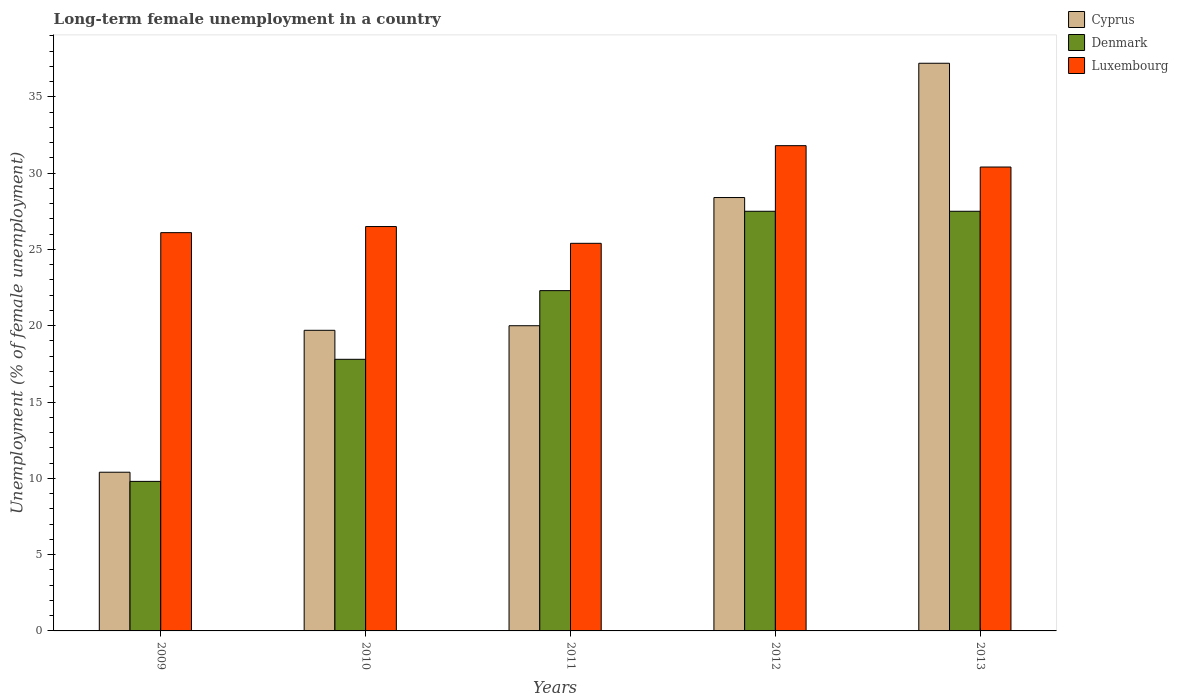How many different coloured bars are there?
Ensure brevity in your answer.  3. How many groups of bars are there?
Your answer should be very brief. 5. Are the number of bars per tick equal to the number of legend labels?
Your answer should be compact. Yes. Are the number of bars on each tick of the X-axis equal?
Your response must be concise. Yes. In how many cases, is the number of bars for a given year not equal to the number of legend labels?
Give a very brief answer. 0. What is the percentage of long-term unemployed female population in Cyprus in 2013?
Provide a succinct answer. 37.2. Across all years, what is the maximum percentage of long-term unemployed female population in Luxembourg?
Provide a succinct answer. 31.8. Across all years, what is the minimum percentage of long-term unemployed female population in Luxembourg?
Make the answer very short. 25.4. In which year was the percentage of long-term unemployed female population in Cyprus maximum?
Offer a very short reply. 2013. What is the total percentage of long-term unemployed female population in Luxembourg in the graph?
Provide a succinct answer. 140.2. What is the difference between the percentage of long-term unemployed female population in Denmark in 2009 and that in 2012?
Provide a short and direct response. -17.7. What is the difference between the percentage of long-term unemployed female population in Denmark in 2011 and the percentage of long-term unemployed female population in Luxembourg in 2013?
Ensure brevity in your answer.  -8.1. What is the average percentage of long-term unemployed female population in Denmark per year?
Provide a succinct answer. 20.98. In the year 2009, what is the difference between the percentage of long-term unemployed female population in Luxembourg and percentage of long-term unemployed female population in Cyprus?
Make the answer very short. 15.7. In how many years, is the percentage of long-term unemployed female population in Denmark greater than 32 %?
Keep it short and to the point. 0. What is the ratio of the percentage of long-term unemployed female population in Luxembourg in 2010 to that in 2012?
Keep it short and to the point. 0.83. Is the percentage of long-term unemployed female population in Cyprus in 2012 less than that in 2013?
Offer a terse response. Yes. Is the difference between the percentage of long-term unemployed female population in Luxembourg in 2011 and 2013 greater than the difference between the percentage of long-term unemployed female population in Cyprus in 2011 and 2013?
Offer a very short reply. Yes. What is the difference between the highest and the second highest percentage of long-term unemployed female population in Luxembourg?
Provide a short and direct response. 1.4. What is the difference between the highest and the lowest percentage of long-term unemployed female population in Luxembourg?
Give a very brief answer. 6.4. Is the sum of the percentage of long-term unemployed female population in Luxembourg in 2009 and 2010 greater than the maximum percentage of long-term unemployed female population in Denmark across all years?
Your answer should be very brief. Yes. What does the 3rd bar from the right in 2009 represents?
Ensure brevity in your answer.  Cyprus. Are all the bars in the graph horizontal?
Offer a terse response. No. Are the values on the major ticks of Y-axis written in scientific E-notation?
Provide a short and direct response. No. Does the graph contain any zero values?
Provide a short and direct response. No. Does the graph contain grids?
Provide a short and direct response. No. Where does the legend appear in the graph?
Keep it short and to the point. Top right. How many legend labels are there?
Offer a very short reply. 3. How are the legend labels stacked?
Make the answer very short. Vertical. What is the title of the graph?
Keep it short and to the point. Long-term female unemployment in a country. Does "Iraq" appear as one of the legend labels in the graph?
Your response must be concise. No. What is the label or title of the Y-axis?
Your answer should be very brief. Unemployment (% of female unemployment). What is the Unemployment (% of female unemployment) in Cyprus in 2009?
Provide a succinct answer. 10.4. What is the Unemployment (% of female unemployment) in Denmark in 2009?
Make the answer very short. 9.8. What is the Unemployment (% of female unemployment) of Luxembourg in 2009?
Provide a succinct answer. 26.1. What is the Unemployment (% of female unemployment) of Cyprus in 2010?
Ensure brevity in your answer.  19.7. What is the Unemployment (% of female unemployment) in Denmark in 2010?
Keep it short and to the point. 17.8. What is the Unemployment (% of female unemployment) in Luxembourg in 2010?
Your response must be concise. 26.5. What is the Unemployment (% of female unemployment) in Denmark in 2011?
Keep it short and to the point. 22.3. What is the Unemployment (% of female unemployment) of Luxembourg in 2011?
Your answer should be very brief. 25.4. What is the Unemployment (% of female unemployment) of Cyprus in 2012?
Ensure brevity in your answer.  28.4. What is the Unemployment (% of female unemployment) in Denmark in 2012?
Offer a terse response. 27.5. What is the Unemployment (% of female unemployment) in Luxembourg in 2012?
Offer a very short reply. 31.8. What is the Unemployment (% of female unemployment) of Cyprus in 2013?
Ensure brevity in your answer.  37.2. What is the Unemployment (% of female unemployment) in Luxembourg in 2013?
Make the answer very short. 30.4. Across all years, what is the maximum Unemployment (% of female unemployment) of Cyprus?
Keep it short and to the point. 37.2. Across all years, what is the maximum Unemployment (% of female unemployment) in Denmark?
Your answer should be compact. 27.5. Across all years, what is the maximum Unemployment (% of female unemployment) in Luxembourg?
Provide a short and direct response. 31.8. Across all years, what is the minimum Unemployment (% of female unemployment) of Cyprus?
Your response must be concise. 10.4. Across all years, what is the minimum Unemployment (% of female unemployment) of Denmark?
Your answer should be compact. 9.8. Across all years, what is the minimum Unemployment (% of female unemployment) of Luxembourg?
Ensure brevity in your answer.  25.4. What is the total Unemployment (% of female unemployment) of Cyprus in the graph?
Keep it short and to the point. 115.7. What is the total Unemployment (% of female unemployment) of Denmark in the graph?
Keep it short and to the point. 104.9. What is the total Unemployment (% of female unemployment) of Luxembourg in the graph?
Offer a terse response. 140.2. What is the difference between the Unemployment (% of female unemployment) in Denmark in 2009 and that in 2010?
Offer a terse response. -8. What is the difference between the Unemployment (% of female unemployment) of Luxembourg in 2009 and that in 2010?
Offer a very short reply. -0.4. What is the difference between the Unemployment (% of female unemployment) of Denmark in 2009 and that in 2011?
Give a very brief answer. -12.5. What is the difference between the Unemployment (% of female unemployment) in Denmark in 2009 and that in 2012?
Provide a succinct answer. -17.7. What is the difference between the Unemployment (% of female unemployment) in Cyprus in 2009 and that in 2013?
Keep it short and to the point. -26.8. What is the difference between the Unemployment (% of female unemployment) of Denmark in 2009 and that in 2013?
Provide a short and direct response. -17.7. What is the difference between the Unemployment (% of female unemployment) in Luxembourg in 2009 and that in 2013?
Offer a terse response. -4.3. What is the difference between the Unemployment (% of female unemployment) of Cyprus in 2010 and that in 2011?
Give a very brief answer. -0.3. What is the difference between the Unemployment (% of female unemployment) of Luxembourg in 2010 and that in 2011?
Give a very brief answer. 1.1. What is the difference between the Unemployment (% of female unemployment) of Cyprus in 2010 and that in 2012?
Your answer should be compact. -8.7. What is the difference between the Unemployment (% of female unemployment) of Cyprus in 2010 and that in 2013?
Give a very brief answer. -17.5. What is the difference between the Unemployment (% of female unemployment) of Denmark in 2010 and that in 2013?
Your response must be concise. -9.7. What is the difference between the Unemployment (% of female unemployment) in Luxembourg in 2010 and that in 2013?
Your answer should be compact. -3.9. What is the difference between the Unemployment (% of female unemployment) in Cyprus in 2011 and that in 2012?
Offer a very short reply. -8.4. What is the difference between the Unemployment (% of female unemployment) of Luxembourg in 2011 and that in 2012?
Your response must be concise. -6.4. What is the difference between the Unemployment (% of female unemployment) in Cyprus in 2011 and that in 2013?
Offer a terse response. -17.2. What is the difference between the Unemployment (% of female unemployment) of Denmark in 2011 and that in 2013?
Keep it short and to the point. -5.2. What is the difference between the Unemployment (% of female unemployment) in Cyprus in 2012 and that in 2013?
Keep it short and to the point. -8.8. What is the difference between the Unemployment (% of female unemployment) of Luxembourg in 2012 and that in 2013?
Offer a terse response. 1.4. What is the difference between the Unemployment (% of female unemployment) of Cyprus in 2009 and the Unemployment (% of female unemployment) of Denmark in 2010?
Offer a terse response. -7.4. What is the difference between the Unemployment (% of female unemployment) of Cyprus in 2009 and the Unemployment (% of female unemployment) of Luxembourg in 2010?
Your answer should be compact. -16.1. What is the difference between the Unemployment (% of female unemployment) in Denmark in 2009 and the Unemployment (% of female unemployment) in Luxembourg in 2010?
Ensure brevity in your answer.  -16.7. What is the difference between the Unemployment (% of female unemployment) in Cyprus in 2009 and the Unemployment (% of female unemployment) in Luxembourg in 2011?
Make the answer very short. -15. What is the difference between the Unemployment (% of female unemployment) in Denmark in 2009 and the Unemployment (% of female unemployment) in Luxembourg in 2011?
Your answer should be very brief. -15.6. What is the difference between the Unemployment (% of female unemployment) in Cyprus in 2009 and the Unemployment (% of female unemployment) in Denmark in 2012?
Provide a succinct answer. -17.1. What is the difference between the Unemployment (% of female unemployment) of Cyprus in 2009 and the Unemployment (% of female unemployment) of Luxembourg in 2012?
Offer a very short reply. -21.4. What is the difference between the Unemployment (% of female unemployment) of Denmark in 2009 and the Unemployment (% of female unemployment) of Luxembourg in 2012?
Your answer should be very brief. -22. What is the difference between the Unemployment (% of female unemployment) in Cyprus in 2009 and the Unemployment (% of female unemployment) in Denmark in 2013?
Your answer should be compact. -17.1. What is the difference between the Unemployment (% of female unemployment) of Denmark in 2009 and the Unemployment (% of female unemployment) of Luxembourg in 2013?
Give a very brief answer. -20.6. What is the difference between the Unemployment (% of female unemployment) in Cyprus in 2010 and the Unemployment (% of female unemployment) in Denmark in 2011?
Keep it short and to the point. -2.6. What is the difference between the Unemployment (% of female unemployment) of Cyprus in 2010 and the Unemployment (% of female unemployment) of Denmark in 2012?
Keep it short and to the point. -7.8. What is the difference between the Unemployment (% of female unemployment) of Cyprus in 2010 and the Unemployment (% of female unemployment) of Luxembourg in 2012?
Give a very brief answer. -12.1. What is the difference between the Unemployment (% of female unemployment) of Denmark in 2010 and the Unemployment (% of female unemployment) of Luxembourg in 2012?
Your response must be concise. -14. What is the difference between the Unemployment (% of female unemployment) in Cyprus in 2010 and the Unemployment (% of female unemployment) in Luxembourg in 2013?
Provide a succinct answer. -10.7. What is the difference between the Unemployment (% of female unemployment) of Cyprus in 2011 and the Unemployment (% of female unemployment) of Denmark in 2012?
Offer a terse response. -7.5. What is the difference between the Unemployment (% of female unemployment) of Denmark in 2011 and the Unemployment (% of female unemployment) of Luxembourg in 2012?
Your response must be concise. -9.5. What is the difference between the Unemployment (% of female unemployment) of Cyprus in 2011 and the Unemployment (% of female unemployment) of Denmark in 2013?
Offer a very short reply. -7.5. What is the difference between the Unemployment (% of female unemployment) in Cyprus in 2011 and the Unemployment (% of female unemployment) in Luxembourg in 2013?
Offer a very short reply. -10.4. What is the difference between the Unemployment (% of female unemployment) of Denmark in 2011 and the Unemployment (% of female unemployment) of Luxembourg in 2013?
Ensure brevity in your answer.  -8.1. What is the difference between the Unemployment (% of female unemployment) of Cyprus in 2012 and the Unemployment (% of female unemployment) of Denmark in 2013?
Your response must be concise. 0.9. What is the difference between the Unemployment (% of female unemployment) in Cyprus in 2012 and the Unemployment (% of female unemployment) in Luxembourg in 2013?
Your response must be concise. -2. What is the difference between the Unemployment (% of female unemployment) in Denmark in 2012 and the Unemployment (% of female unemployment) in Luxembourg in 2013?
Provide a succinct answer. -2.9. What is the average Unemployment (% of female unemployment) of Cyprus per year?
Your response must be concise. 23.14. What is the average Unemployment (% of female unemployment) in Denmark per year?
Offer a terse response. 20.98. What is the average Unemployment (% of female unemployment) in Luxembourg per year?
Offer a terse response. 28.04. In the year 2009, what is the difference between the Unemployment (% of female unemployment) of Cyprus and Unemployment (% of female unemployment) of Denmark?
Offer a very short reply. 0.6. In the year 2009, what is the difference between the Unemployment (% of female unemployment) of Cyprus and Unemployment (% of female unemployment) of Luxembourg?
Ensure brevity in your answer.  -15.7. In the year 2009, what is the difference between the Unemployment (% of female unemployment) in Denmark and Unemployment (% of female unemployment) in Luxembourg?
Ensure brevity in your answer.  -16.3. In the year 2010, what is the difference between the Unemployment (% of female unemployment) of Cyprus and Unemployment (% of female unemployment) of Denmark?
Offer a terse response. 1.9. In the year 2010, what is the difference between the Unemployment (% of female unemployment) in Cyprus and Unemployment (% of female unemployment) in Luxembourg?
Offer a very short reply. -6.8. In the year 2011, what is the difference between the Unemployment (% of female unemployment) of Cyprus and Unemployment (% of female unemployment) of Denmark?
Provide a short and direct response. -2.3. In the year 2011, what is the difference between the Unemployment (% of female unemployment) in Cyprus and Unemployment (% of female unemployment) in Luxembourg?
Give a very brief answer. -5.4. In the year 2011, what is the difference between the Unemployment (% of female unemployment) in Denmark and Unemployment (% of female unemployment) in Luxembourg?
Provide a succinct answer. -3.1. In the year 2012, what is the difference between the Unemployment (% of female unemployment) in Cyprus and Unemployment (% of female unemployment) in Denmark?
Your response must be concise. 0.9. In the year 2012, what is the difference between the Unemployment (% of female unemployment) of Denmark and Unemployment (% of female unemployment) of Luxembourg?
Ensure brevity in your answer.  -4.3. In the year 2013, what is the difference between the Unemployment (% of female unemployment) of Cyprus and Unemployment (% of female unemployment) of Luxembourg?
Offer a terse response. 6.8. What is the ratio of the Unemployment (% of female unemployment) of Cyprus in 2009 to that in 2010?
Provide a short and direct response. 0.53. What is the ratio of the Unemployment (% of female unemployment) of Denmark in 2009 to that in 2010?
Provide a short and direct response. 0.55. What is the ratio of the Unemployment (% of female unemployment) of Luxembourg in 2009 to that in 2010?
Your answer should be very brief. 0.98. What is the ratio of the Unemployment (% of female unemployment) in Cyprus in 2009 to that in 2011?
Keep it short and to the point. 0.52. What is the ratio of the Unemployment (% of female unemployment) of Denmark in 2009 to that in 2011?
Your answer should be very brief. 0.44. What is the ratio of the Unemployment (% of female unemployment) of Luxembourg in 2009 to that in 2011?
Keep it short and to the point. 1.03. What is the ratio of the Unemployment (% of female unemployment) of Cyprus in 2009 to that in 2012?
Offer a terse response. 0.37. What is the ratio of the Unemployment (% of female unemployment) of Denmark in 2009 to that in 2012?
Offer a terse response. 0.36. What is the ratio of the Unemployment (% of female unemployment) of Luxembourg in 2009 to that in 2012?
Provide a succinct answer. 0.82. What is the ratio of the Unemployment (% of female unemployment) in Cyprus in 2009 to that in 2013?
Your response must be concise. 0.28. What is the ratio of the Unemployment (% of female unemployment) of Denmark in 2009 to that in 2013?
Offer a terse response. 0.36. What is the ratio of the Unemployment (% of female unemployment) of Luxembourg in 2009 to that in 2013?
Your answer should be compact. 0.86. What is the ratio of the Unemployment (% of female unemployment) in Denmark in 2010 to that in 2011?
Offer a very short reply. 0.8. What is the ratio of the Unemployment (% of female unemployment) of Luxembourg in 2010 to that in 2011?
Provide a short and direct response. 1.04. What is the ratio of the Unemployment (% of female unemployment) in Cyprus in 2010 to that in 2012?
Your answer should be very brief. 0.69. What is the ratio of the Unemployment (% of female unemployment) in Denmark in 2010 to that in 2012?
Give a very brief answer. 0.65. What is the ratio of the Unemployment (% of female unemployment) of Luxembourg in 2010 to that in 2012?
Your answer should be compact. 0.83. What is the ratio of the Unemployment (% of female unemployment) of Cyprus in 2010 to that in 2013?
Ensure brevity in your answer.  0.53. What is the ratio of the Unemployment (% of female unemployment) in Denmark in 2010 to that in 2013?
Your answer should be compact. 0.65. What is the ratio of the Unemployment (% of female unemployment) in Luxembourg in 2010 to that in 2013?
Provide a succinct answer. 0.87. What is the ratio of the Unemployment (% of female unemployment) in Cyprus in 2011 to that in 2012?
Provide a short and direct response. 0.7. What is the ratio of the Unemployment (% of female unemployment) in Denmark in 2011 to that in 2012?
Provide a short and direct response. 0.81. What is the ratio of the Unemployment (% of female unemployment) of Luxembourg in 2011 to that in 2012?
Your response must be concise. 0.8. What is the ratio of the Unemployment (% of female unemployment) in Cyprus in 2011 to that in 2013?
Keep it short and to the point. 0.54. What is the ratio of the Unemployment (% of female unemployment) of Denmark in 2011 to that in 2013?
Make the answer very short. 0.81. What is the ratio of the Unemployment (% of female unemployment) of Luxembourg in 2011 to that in 2013?
Make the answer very short. 0.84. What is the ratio of the Unemployment (% of female unemployment) of Cyprus in 2012 to that in 2013?
Your answer should be compact. 0.76. What is the ratio of the Unemployment (% of female unemployment) of Denmark in 2012 to that in 2013?
Ensure brevity in your answer.  1. What is the ratio of the Unemployment (% of female unemployment) in Luxembourg in 2012 to that in 2013?
Make the answer very short. 1.05. What is the difference between the highest and the second highest Unemployment (% of female unemployment) in Cyprus?
Make the answer very short. 8.8. What is the difference between the highest and the second highest Unemployment (% of female unemployment) of Denmark?
Keep it short and to the point. 0. What is the difference between the highest and the second highest Unemployment (% of female unemployment) in Luxembourg?
Your response must be concise. 1.4. What is the difference between the highest and the lowest Unemployment (% of female unemployment) in Cyprus?
Offer a terse response. 26.8. 